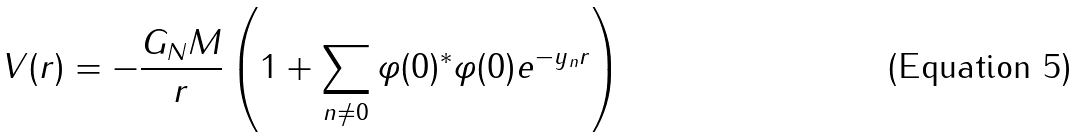Convert formula to latex. <formula><loc_0><loc_0><loc_500><loc_500>V ( r ) = - \frac { G _ { N } M } { r } \left ( 1 + \sum _ { n \neq 0 } \varphi ( 0 ) ^ { * } \varphi ( 0 ) e ^ { - y _ { n } r } \right )</formula> 